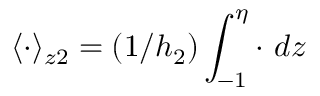Convert formula to latex. <formula><loc_0><loc_0><loc_500><loc_500>\langle \cdot \rangle _ { z 2 } = ( 1 / h _ { 2 } ) \int _ { - 1 } ^ { \eta } \cdot \ d z</formula> 